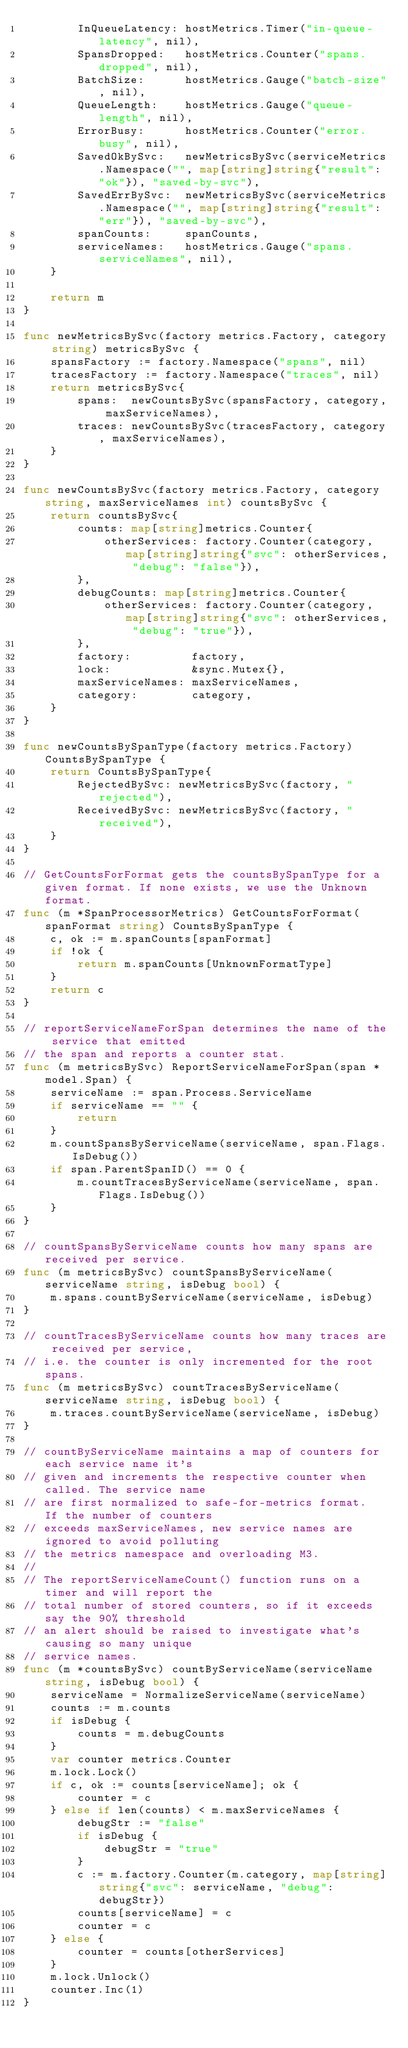<code> <loc_0><loc_0><loc_500><loc_500><_Go_>		InQueueLatency: hostMetrics.Timer("in-queue-latency", nil),
		SpansDropped:   hostMetrics.Counter("spans.dropped", nil),
		BatchSize:      hostMetrics.Gauge("batch-size", nil),
		QueueLength:    hostMetrics.Gauge("queue-length", nil),
		ErrorBusy:      hostMetrics.Counter("error.busy", nil),
		SavedOkBySvc:   newMetricsBySvc(serviceMetrics.Namespace("", map[string]string{"result": "ok"}), "saved-by-svc"),
		SavedErrBySvc:  newMetricsBySvc(serviceMetrics.Namespace("", map[string]string{"result": "err"}), "saved-by-svc"),
		spanCounts:     spanCounts,
		serviceNames:   hostMetrics.Gauge("spans.serviceNames", nil),
	}

	return m
}

func newMetricsBySvc(factory metrics.Factory, category string) metricsBySvc {
	spansFactory := factory.Namespace("spans", nil)
	tracesFactory := factory.Namespace("traces", nil)
	return metricsBySvc{
		spans:  newCountsBySvc(spansFactory, category, maxServiceNames),
		traces: newCountsBySvc(tracesFactory, category, maxServiceNames),
	}
}

func newCountsBySvc(factory metrics.Factory, category string, maxServiceNames int) countsBySvc {
	return countsBySvc{
		counts: map[string]metrics.Counter{
			otherServices: factory.Counter(category, map[string]string{"svc": otherServices, "debug": "false"}),
		},
		debugCounts: map[string]metrics.Counter{
			otherServices: factory.Counter(category, map[string]string{"svc": otherServices, "debug": "true"}),
		},
		factory:         factory,
		lock:            &sync.Mutex{},
		maxServiceNames: maxServiceNames,
		category:        category,
	}
}

func newCountsBySpanType(factory metrics.Factory) CountsBySpanType {
	return CountsBySpanType{
		RejectedBySvc: newMetricsBySvc(factory, "rejected"),
		ReceivedBySvc: newMetricsBySvc(factory, "received"),
	}
}

// GetCountsForFormat gets the countsBySpanType for a given format. If none exists, we use the Unknown format.
func (m *SpanProcessorMetrics) GetCountsForFormat(spanFormat string) CountsBySpanType {
	c, ok := m.spanCounts[spanFormat]
	if !ok {
		return m.spanCounts[UnknownFormatType]
	}
	return c
}

// reportServiceNameForSpan determines the name of the service that emitted
// the span and reports a counter stat.
func (m metricsBySvc) ReportServiceNameForSpan(span *model.Span) {
	serviceName := span.Process.ServiceName
	if serviceName == "" {
		return
	}
	m.countSpansByServiceName(serviceName, span.Flags.IsDebug())
	if span.ParentSpanID() == 0 {
		m.countTracesByServiceName(serviceName, span.Flags.IsDebug())
	}
}

// countSpansByServiceName counts how many spans are received per service.
func (m metricsBySvc) countSpansByServiceName(serviceName string, isDebug bool) {
	m.spans.countByServiceName(serviceName, isDebug)
}

// countTracesByServiceName counts how many traces are received per service,
// i.e. the counter is only incremented for the root spans.
func (m metricsBySvc) countTracesByServiceName(serviceName string, isDebug bool) {
	m.traces.countByServiceName(serviceName, isDebug)
}

// countByServiceName maintains a map of counters for each service name it's
// given and increments the respective counter when called. The service name
// are first normalized to safe-for-metrics format.  If the number of counters
// exceeds maxServiceNames, new service names are ignored to avoid polluting
// the metrics namespace and overloading M3.
//
// The reportServiceNameCount() function runs on a timer and will report the
// total number of stored counters, so if it exceeds say the 90% threshold
// an alert should be raised to investigate what's causing so many unique
// service names.
func (m *countsBySvc) countByServiceName(serviceName string, isDebug bool) {
	serviceName = NormalizeServiceName(serviceName)
	counts := m.counts
	if isDebug {
		counts = m.debugCounts
	}
	var counter metrics.Counter
	m.lock.Lock()
	if c, ok := counts[serviceName]; ok {
		counter = c
	} else if len(counts) < m.maxServiceNames {
		debugStr := "false"
		if isDebug {
			debugStr = "true"
		}
		c := m.factory.Counter(m.category, map[string]string{"svc": serviceName, "debug": debugStr})
		counts[serviceName] = c
		counter = c
	} else {
		counter = counts[otherServices]
	}
	m.lock.Unlock()
	counter.Inc(1)
}
</code> 